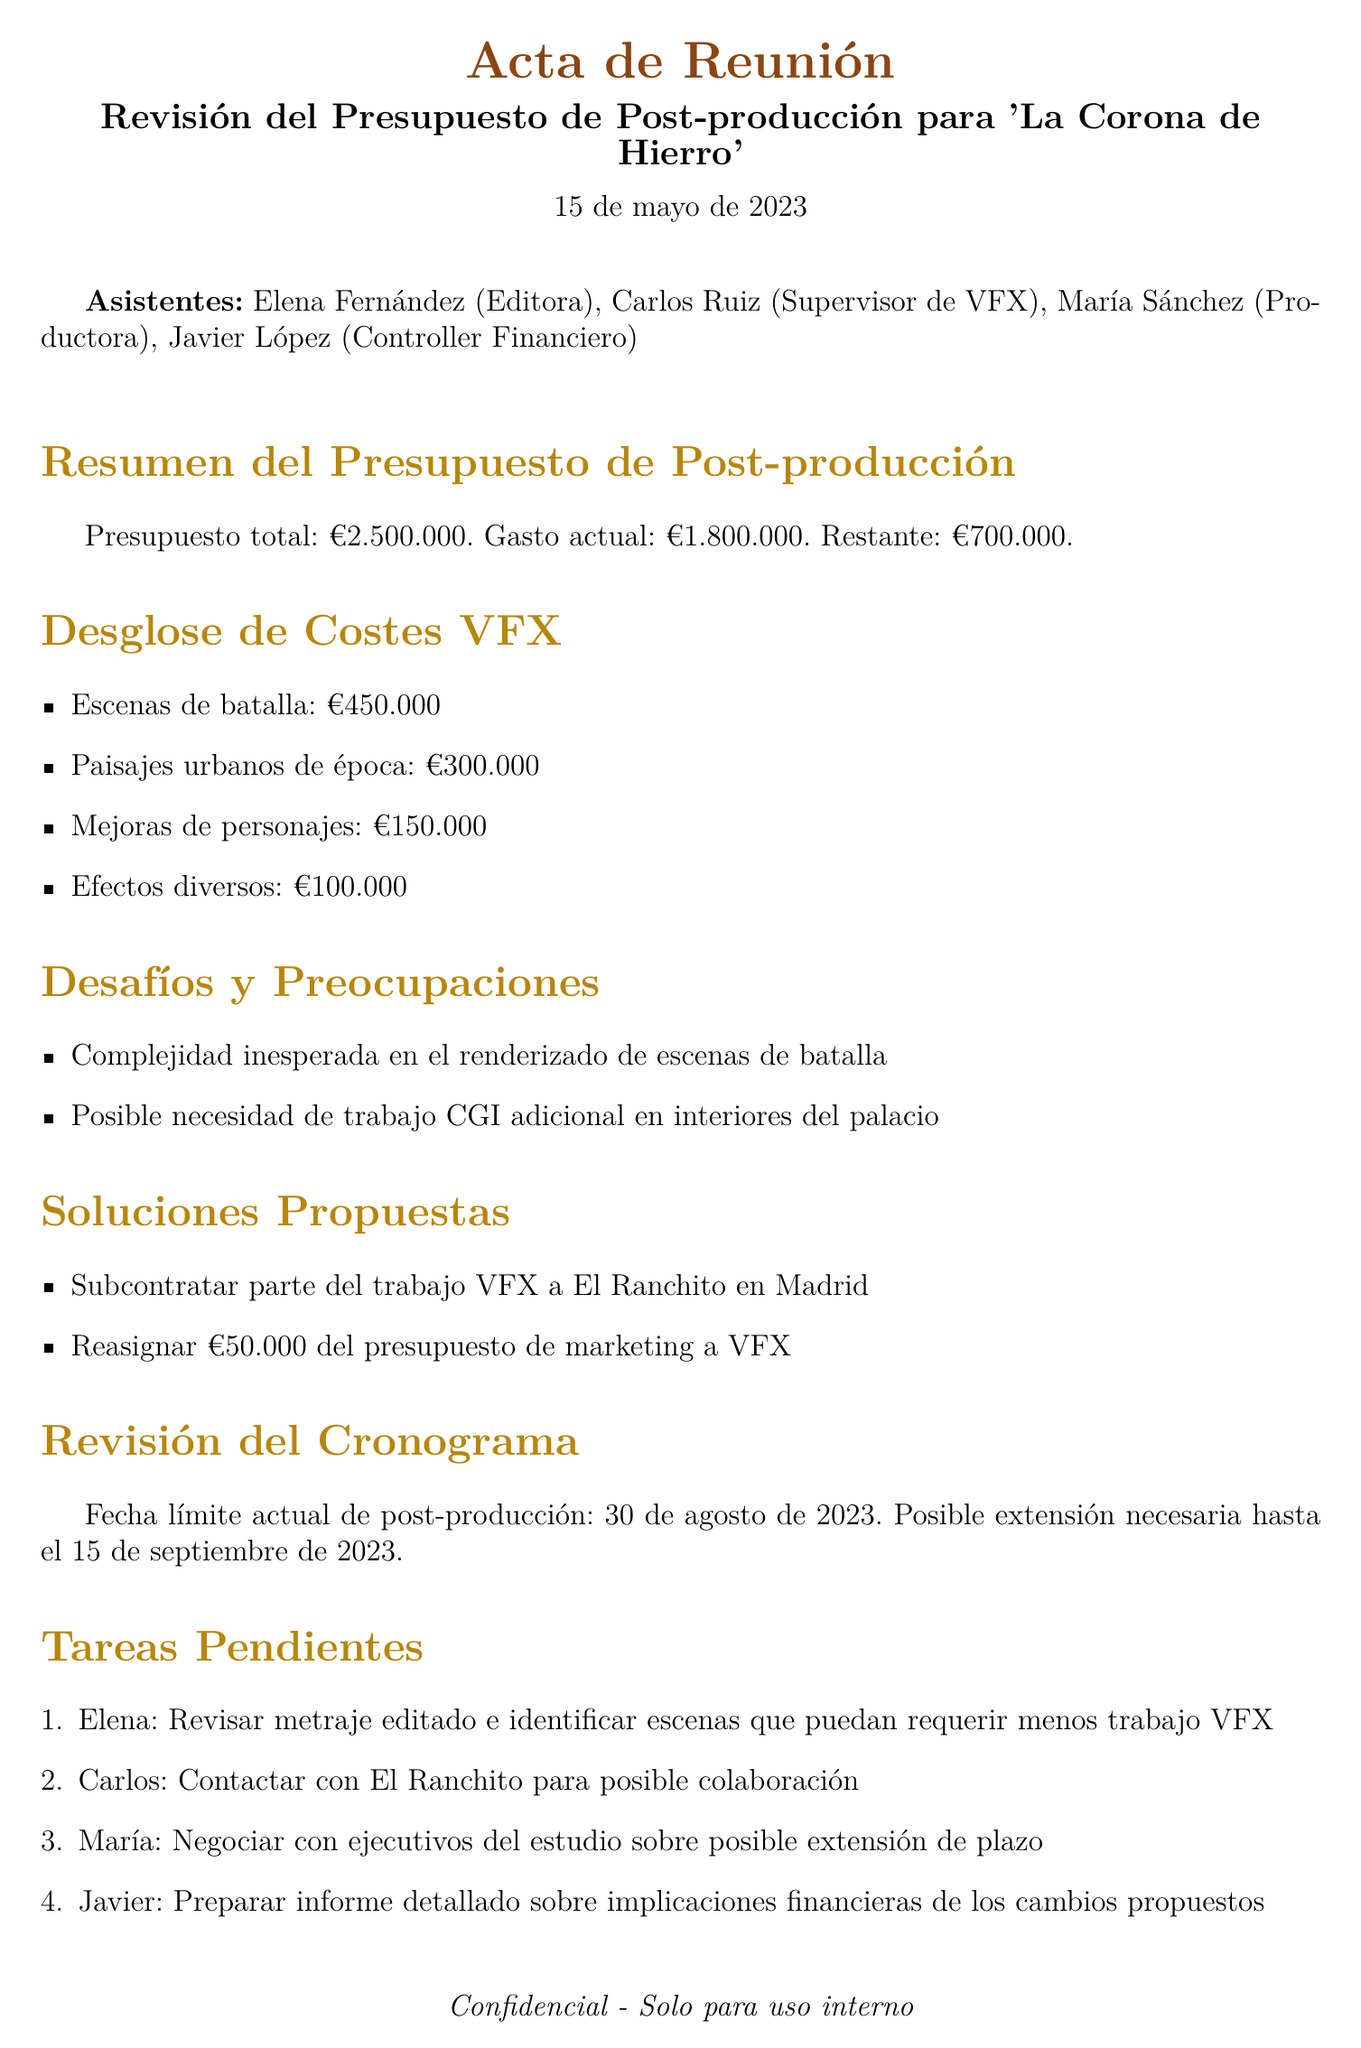What is the total post-production budget? The total post-production budget is provided in the overview section of the document.
Answer: €2,500,000 What is the current expenditure on the project? The current expenditure is detailed right after the total budget in the document.
Answer: €1,800,000 How much budget is remaining for post-production? The remaining budget is calculated from the total and current expenditure listed in the document.
Answer: €700,000 What is the cost for battle scenes VFX? The cost for battle scenes is explicitly stated in the breakdown of VFX costs.
Answer: €450,000 What potential solution involves outsourcing? The proposed solution mentions outsourcing and the company involved in Madrid.
Answer: El Ranchito What is the current deadline for post-production? The current post-production deadline is directly mentioned in the timeline review section.
Answer: August 30, 2023 What is one of the challenges faced in the VFX section? One of the challenges listed pertains to the complexity of a specific type of scene.
Answer: Unexpected complexity in battle scene renderings Who is responsible for contacting El Ranchito? The action item specifies who will take charge of contacting the company.
Answer: Carlos What amount is proposed to be reallocated from the marketing budget? The document specifies the amount to be reallocated in the proposed solutions section.
Answer: €50,000 